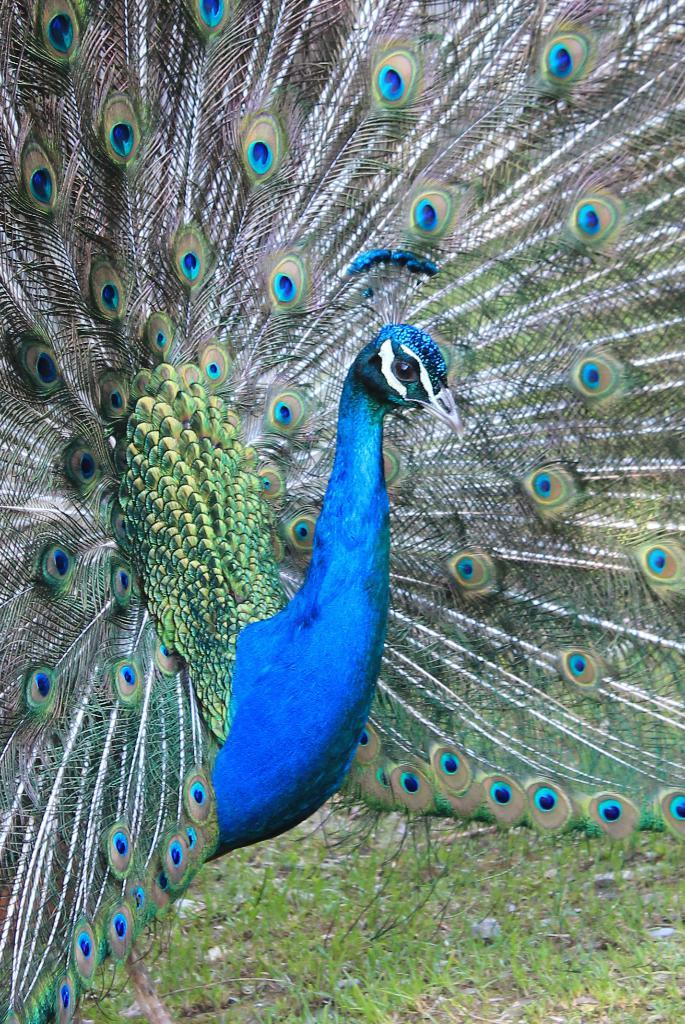What type of animal is in the image? There is a peacock in the image. What feature of the peacock is particularly noticeable? The peacock has feathers. Where is the peacock located in the image? The peacock is standing on the ground. What type of vegetation is on the ground? There is grass on the ground. Can you see any fairies flying around the peacock in the image? There are no fairies present in the image. What type of ticket is the peacock holding in the image? The peacock is not holding any ticket in the image. 